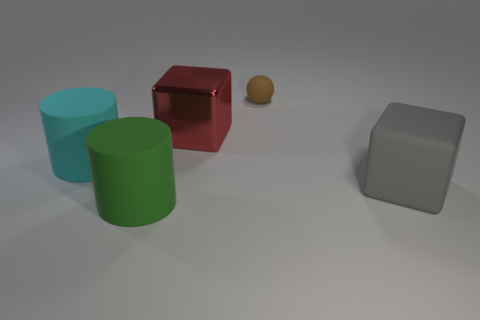Add 5 big cyan cylinders. How many objects exist? 10 Subtract all cubes. How many objects are left? 3 Subtract all big red shiny blocks. Subtract all cyan things. How many objects are left? 3 Add 5 large cylinders. How many large cylinders are left? 7 Add 5 brown shiny blocks. How many brown shiny blocks exist? 5 Subtract 1 cyan cylinders. How many objects are left? 4 